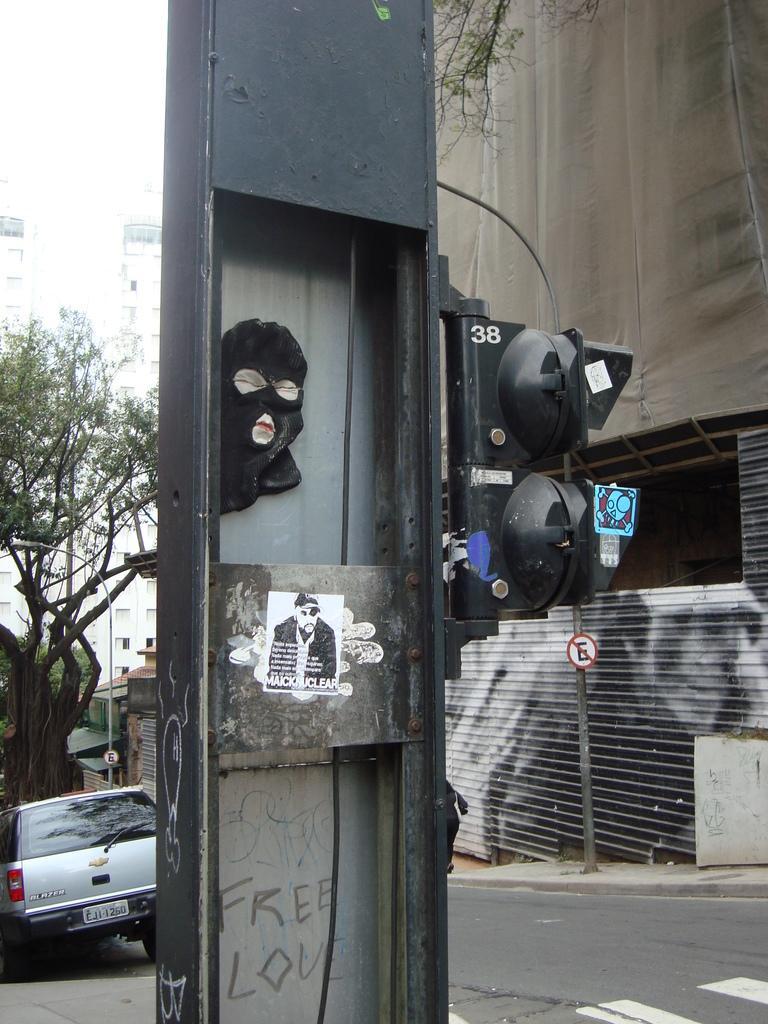Describe this image in one or two sentences. In this image I can see a pole in the front and on it I can see a black colour face mask, a paper and few lights. In the background I can see a road, a car, few trees, few sign boards and few buildings. 